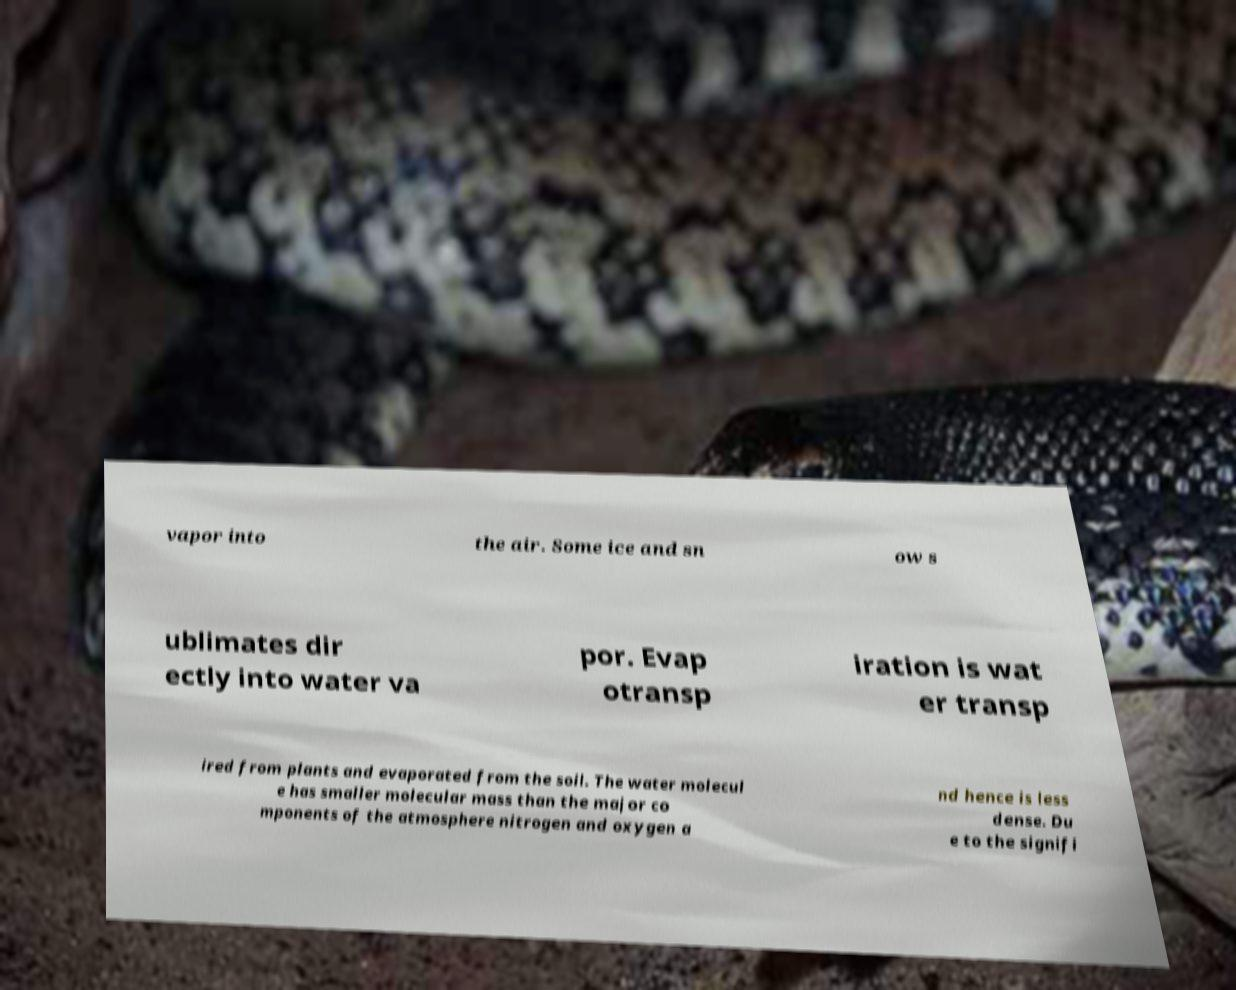Could you extract and type out the text from this image? vapor into the air. Some ice and sn ow s ublimates dir ectly into water va por. Evap otransp iration is wat er transp ired from plants and evaporated from the soil. The water molecul e has smaller molecular mass than the major co mponents of the atmosphere nitrogen and oxygen a nd hence is less dense. Du e to the signifi 